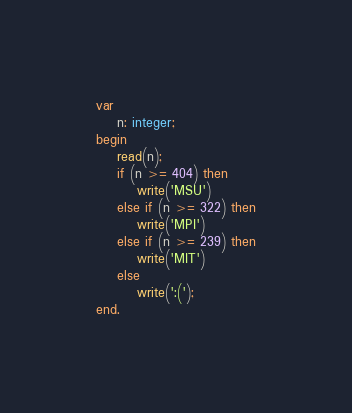Convert code to text. <code><loc_0><loc_0><loc_500><loc_500><_Pascal_>var
    n: integer;
begin
    read(n);
    if (n >= 404) then
        write('MSU')
    else if (n >= 322) then
        write('MPI')
    else if (n >= 239) then
        write('MIT')
    else
        write(':(');
end.
</code> 